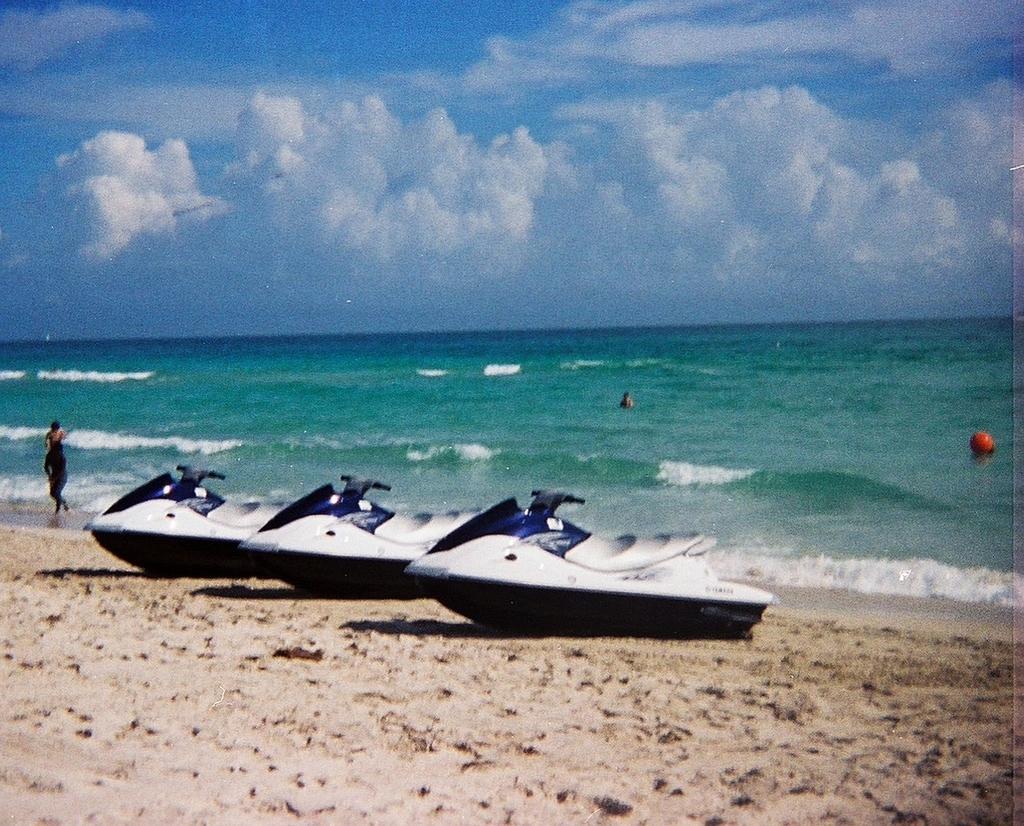Describe this image in one or two sentences. In the center of the image there are three ski trailers. At the bottom of the image there is sand. In the background of the image there is water,sky and clouds. There is a person walking to the left side of the image. To the right side of the image there is ball. 